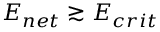Convert formula to latex. <formula><loc_0><loc_0><loc_500><loc_500>E _ { n e t } \gtrsim E _ { c r i t }</formula> 